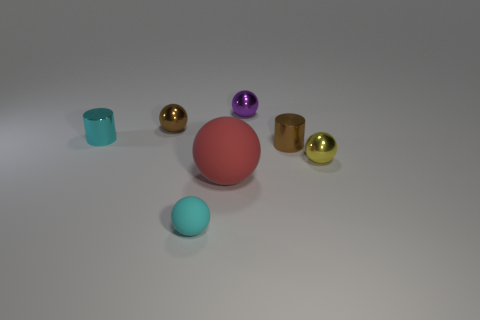Is there a big brown cube?
Give a very brief answer. No. What is the color of the matte thing that is the same size as the cyan cylinder?
Your response must be concise. Cyan. What number of tiny brown objects have the same shape as the large red object?
Your response must be concise. 1. Is the material of the large red object that is left of the small purple metallic ball the same as the tiny cyan ball?
Give a very brief answer. Yes. What number of balls are either purple objects or small cyan rubber objects?
Give a very brief answer. 2. The brown thing that is left of the small thing that is in front of the metallic sphere that is in front of the tiny cyan cylinder is what shape?
Your answer should be compact. Sphere. There is a shiny thing that is the same color as the tiny matte ball; what shape is it?
Provide a short and direct response. Cylinder. What number of cyan shiny cubes have the same size as the purple metal sphere?
Ensure brevity in your answer.  0. There is a small cyan thing that is in front of the small yellow object; is there a small ball to the left of it?
Your response must be concise. Yes. How many objects are yellow balls or small brown objects?
Your answer should be very brief. 3. 